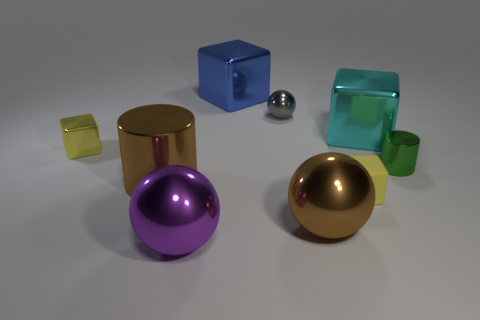There is a brown sphere; how many gray spheres are right of it?
Offer a very short reply. 0. The tiny metal cylinder has what color?
Provide a short and direct response. Green. How many big things are green things or yellow cubes?
Provide a short and direct response. 0. There is a tiny metallic thing that is on the left side of the purple metal object; does it have the same color as the metal cylinder that is on the left side of the green metal cylinder?
Your answer should be very brief. No. How many other objects are there of the same color as the tiny metal cylinder?
Provide a short and direct response. 0. There is a big brown metallic object that is to the left of the large blue thing; what shape is it?
Give a very brief answer. Cylinder. Are there fewer green cylinders than tiny gray rubber spheres?
Provide a short and direct response. No. Is the material of the cylinder on the right side of the purple sphere the same as the big blue cube?
Give a very brief answer. Yes. Is there any other thing that has the same size as the yellow metallic thing?
Keep it short and to the point. Yes. Are there any small balls in front of the gray object?
Provide a succinct answer. No. 